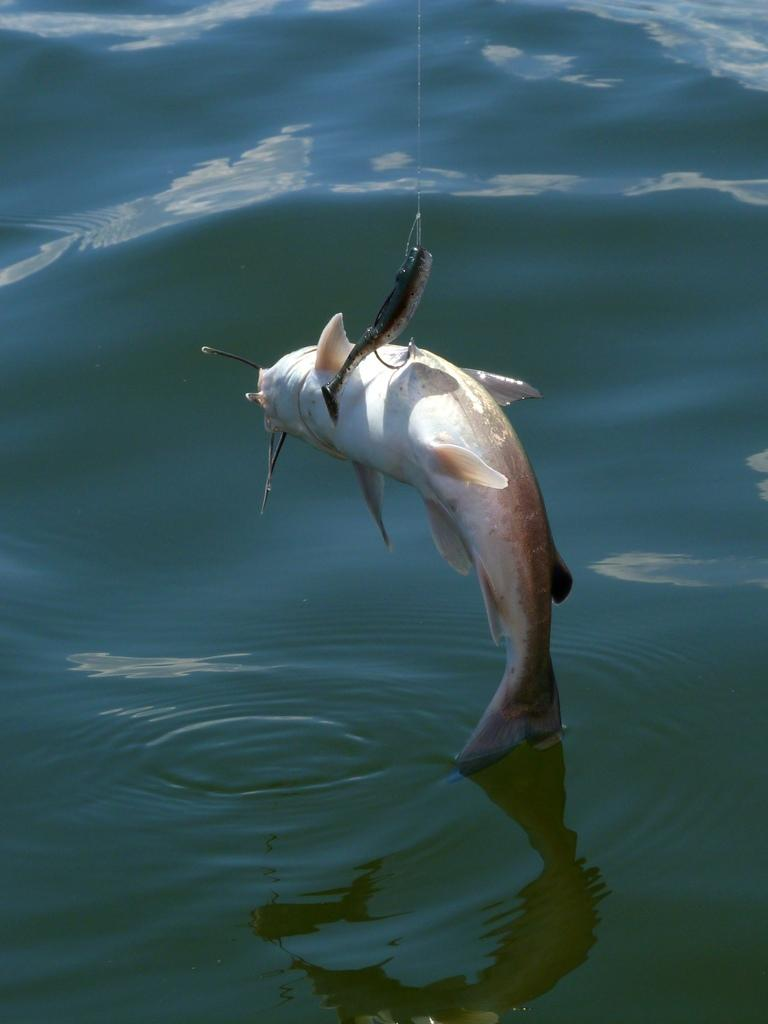What type of animals can be seen in the image? There are fishes in the image. What is the primary element in which the fishes are situated? There is water visible in the image. How many apples can be seen in the image? There are no apples present in the image. What type of thing is walking in the image? There is no thing walking in the image, as it features fishes in water. 